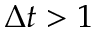Convert formula to latex. <formula><loc_0><loc_0><loc_500><loc_500>\Delta t > 1</formula> 